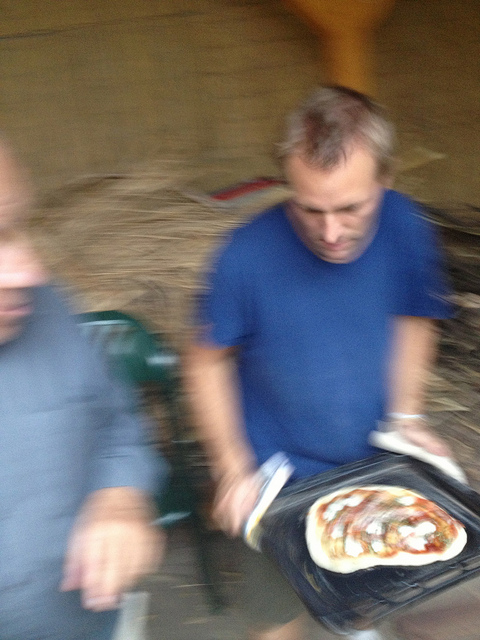<image>What is the guy holding? I am not sure. The guy may be holding a pan of pizza or a pizza on a pan. What is the guy holding? I don't know what the guy is holding. It can be seen as a pan of pizza or just pizza. 